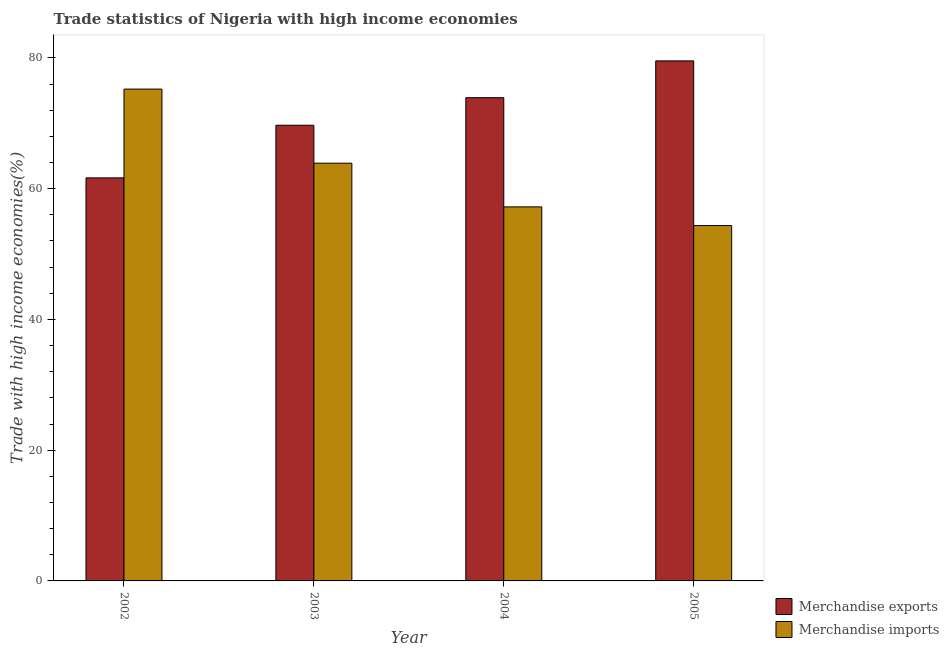How many different coloured bars are there?
Your answer should be very brief. 2. How many groups of bars are there?
Your response must be concise. 4. Are the number of bars on each tick of the X-axis equal?
Offer a terse response. Yes. How many bars are there on the 1st tick from the left?
Provide a short and direct response. 2. How many bars are there on the 2nd tick from the right?
Provide a short and direct response. 2. What is the label of the 4th group of bars from the left?
Keep it short and to the point. 2005. What is the merchandise imports in 2003?
Provide a short and direct response. 63.9. Across all years, what is the maximum merchandise exports?
Your answer should be very brief. 79.55. Across all years, what is the minimum merchandise imports?
Offer a very short reply. 54.36. In which year was the merchandise exports maximum?
Your answer should be compact. 2005. What is the total merchandise exports in the graph?
Give a very brief answer. 284.83. What is the difference between the merchandise exports in 2003 and that in 2005?
Keep it short and to the point. -9.85. What is the difference between the merchandise imports in 2005 and the merchandise exports in 2002?
Ensure brevity in your answer.  -20.88. What is the average merchandise exports per year?
Provide a short and direct response. 71.21. In the year 2005, what is the difference between the merchandise imports and merchandise exports?
Provide a succinct answer. 0. In how many years, is the merchandise exports greater than 64 %?
Offer a very short reply. 3. What is the ratio of the merchandise imports in 2002 to that in 2004?
Give a very brief answer. 1.31. Is the merchandise exports in 2002 less than that in 2005?
Provide a succinct answer. Yes. Is the difference between the merchandise imports in 2004 and 2005 greater than the difference between the merchandise exports in 2004 and 2005?
Provide a short and direct response. No. What is the difference between the highest and the second highest merchandise imports?
Provide a succinct answer. 11.33. What is the difference between the highest and the lowest merchandise exports?
Provide a succinct answer. 17.9. Is the sum of the merchandise imports in 2003 and 2004 greater than the maximum merchandise exports across all years?
Offer a very short reply. Yes. How many bars are there?
Your response must be concise. 8. Are all the bars in the graph horizontal?
Offer a very short reply. No. How many years are there in the graph?
Make the answer very short. 4. What is the difference between two consecutive major ticks on the Y-axis?
Make the answer very short. 20. Are the values on the major ticks of Y-axis written in scientific E-notation?
Your answer should be very brief. No. Does the graph contain any zero values?
Provide a short and direct response. No. Does the graph contain grids?
Ensure brevity in your answer.  No. Where does the legend appear in the graph?
Provide a short and direct response. Bottom right. How many legend labels are there?
Keep it short and to the point. 2. What is the title of the graph?
Keep it short and to the point. Trade statistics of Nigeria with high income economies. What is the label or title of the X-axis?
Your answer should be compact. Year. What is the label or title of the Y-axis?
Give a very brief answer. Trade with high income economies(%). What is the Trade with high income economies(%) in Merchandise exports in 2002?
Keep it short and to the point. 61.65. What is the Trade with high income economies(%) of Merchandise imports in 2002?
Your answer should be very brief. 75.23. What is the Trade with high income economies(%) of Merchandise exports in 2003?
Offer a terse response. 69.7. What is the Trade with high income economies(%) in Merchandise imports in 2003?
Make the answer very short. 63.9. What is the Trade with high income economies(%) in Merchandise exports in 2004?
Your response must be concise. 73.92. What is the Trade with high income economies(%) in Merchandise imports in 2004?
Provide a succinct answer. 57.22. What is the Trade with high income economies(%) of Merchandise exports in 2005?
Your answer should be compact. 79.55. What is the Trade with high income economies(%) of Merchandise imports in 2005?
Your response must be concise. 54.36. Across all years, what is the maximum Trade with high income economies(%) in Merchandise exports?
Your answer should be very brief. 79.55. Across all years, what is the maximum Trade with high income economies(%) in Merchandise imports?
Ensure brevity in your answer.  75.23. Across all years, what is the minimum Trade with high income economies(%) of Merchandise exports?
Make the answer very short. 61.65. Across all years, what is the minimum Trade with high income economies(%) of Merchandise imports?
Make the answer very short. 54.36. What is the total Trade with high income economies(%) of Merchandise exports in the graph?
Provide a succinct answer. 284.83. What is the total Trade with high income economies(%) in Merchandise imports in the graph?
Ensure brevity in your answer.  250.71. What is the difference between the Trade with high income economies(%) in Merchandise exports in 2002 and that in 2003?
Your answer should be compact. -8.05. What is the difference between the Trade with high income economies(%) in Merchandise imports in 2002 and that in 2003?
Provide a short and direct response. 11.33. What is the difference between the Trade with high income economies(%) of Merchandise exports in 2002 and that in 2004?
Provide a succinct answer. -12.27. What is the difference between the Trade with high income economies(%) in Merchandise imports in 2002 and that in 2004?
Offer a very short reply. 18.02. What is the difference between the Trade with high income economies(%) in Merchandise exports in 2002 and that in 2005?
Make the answer very short. -17.9. What is the difference between the Trade with high income economies(%) in Merchandise imports in 2002 and that in 2005?
Make the answer very short. 20.88. What is the difference between the Trade with high income economies(%) in Merchandise exports in 2003 and that in 2004?
Your response must be concise. -4.22. What is the difference between the Trade with high income economies(%) of Merchandise imports in 2003 and that in 2004?
Make the answer very short. 6.68. What is the difference between the Trade with high income economies(%) in Merchandise exports in 2003 and that in 2005?
Make the answer very short. -9.85. What is the difference between the Trade with high income economies(%) in Merchandise imports in 2003 and that in 2005?
Your response must be concise. 9.54. What is the difference between the Trade with high income economies(%) of Merchandise exports in 2004 and that in 2005?
Your answer should be compact. -5.63. What is the difference between the Trade with high income economies(%) in Merchandise imports in 2004 and that in 2005?
Provide a short and direct response. 2.86. What is the difference between the Trade with high income economies(%) in Merchandise exports in 2002 and the Trade with high income economies(%) in Merchandise imports in 2003?
Make the answer very short. -2.25. What is the difference between the Trade with high income economies(%) of Merchandise exports in 2002 and the Trade with high income economies(%) of Merchandise imports in 2004?
Make the answer very short. 4.44. What is the difference between the Trade with high income economies(%) of Merchandise exports in 2002 and the Trade with high income economies(%) of Merchandise imports in 2005?
Keep it short and to the point. 7.3. What is the difference between the Trade with high income economies(%) of Merchandise exports in 2003 and the Trade with high income economies(%) of Merchandise imports in 2004?
Your response must be concise. 12.49. What is the difference between the Trade with high income economies(%) in Merchandise exports in 2003 and the Trade with high income economies(%) in Merchandise imports in 2005?
Make the answer very short. 15.35. What is the difference between the Trade with high income economies(%) in Merchandise exports in 2004 and the Trade with high income economies(%) in Merchandise imports in 2005?
Ensure brevity in your answer.  19.56. What is the average Trade with high income economies(%) of Merchandise exports per year?
Provide a succinct answer. 71.21. What is the average Trade with high income economies(%) of Merchandise imports per year?
Keep it short and to the point. 62.68. In the year 2002, what is the difference between the Trade with high income economies(%) of Merchandise exports and Trade with high income economies(%) of Merchandise imports?
Provide a short and direct response. -13.58. In the year 2003, what is the difference between the Trade with high income economies(%) in Merchandise exports and Trade with high income economies(%) in Merchandise imports?
Ensure brevity in your answer.  5.8. In the year 2004, what is the difference between the Trade with high income economies(%) in Merchandise exports and Trade with high income economies(%) in Merchandise imports?
Provide a short and direct response. 16.7. In the year 2005, what is the difference between the Trade with high income economies(%) in Merchandise exports and Trade with high income economies(%) in Merchandise imports?
Provide a succinct answer. 25.19. What is the ratio of the Trade with high income economies(%) of Merchandise exports in 2002 to that in 2003?
Provide a succinct answer. 0.88. What is the ratio of the Trade with high income economies(%) in Merchandise imports in 2002 to that in 2003?
Your answer should be very brief. 1.18. What is the ratio of the Trade with high income economies(%) in Merchandise exports in 2002 to that in 2004?
Provide a succinct answer. 0.83. What is the ratio of the Trade with high income economies(%) of Merchandise imports in 2002 to that in 2004?
Your answer should be compact. 1.31. What is the ratio of the Trade with high income economies(%) of Merchandise exports in 2002 to that in 2005?
Make the answer very short. 0.78. What is the ratio of the Trade with high income economies(%) of Merchandise imports in 2002 to that in 2005?
Offer a very short reply. 1.38. What is the ratio of the Trade with high income economies(%) in Merchandise exports in 2003 to that in 2004?
Provide a succinct answer. 0.94. What is the ratio of the Trade with high income economies(%) in Merchandise imports in 2003 to that in 2004?
Ensure brevity in your answer.  1.12. What is the ratio of the Trade with high income economies(%) of Merchandise exports in 2003 to that in 2005?
Your response must be concise. 0.88. What is the ratio of the Trade with high income economies(%) of Merchandise imports in 2003 to that in 2005?
Keep it short and to the point. 1.18. What is the ratio of the Trade with high income economies(%) of Merchandise exports in 2004 to that in 2005?
Make the answer very short. 0.93. What is the ratio of the Trade with high income economies(%) in Merchandise imports in 2004 to that in 2005?
Keep it short and to the point. 1.05. What is the difference between the highest and the second highest Trade with high income economies(%) of Merchandise exports?
Your answer should be very brief. 5.63. What is the difference between the highest and the second highest Trade with high income economies(%) of Merchandise imports?
Offer a terse response. 11.33. What is the difference between the highest and the lowest Trade with high income economies(%) of Merchandise exports?
Your response must be concise. 17.9. What is the difference between the highest and the lowest Trade with high income economies(%) in Merchandise imports?
Provide a succinct answer. 20.88. 